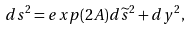Convert formula to latex. <formula><loc_0><loc_0><loc_500><loc_500>d s ^ { 2 } = e x p ( 2 A ) d \widetilde { s } ^ { 2 } + d y ^ { 2 } ,</formula> 